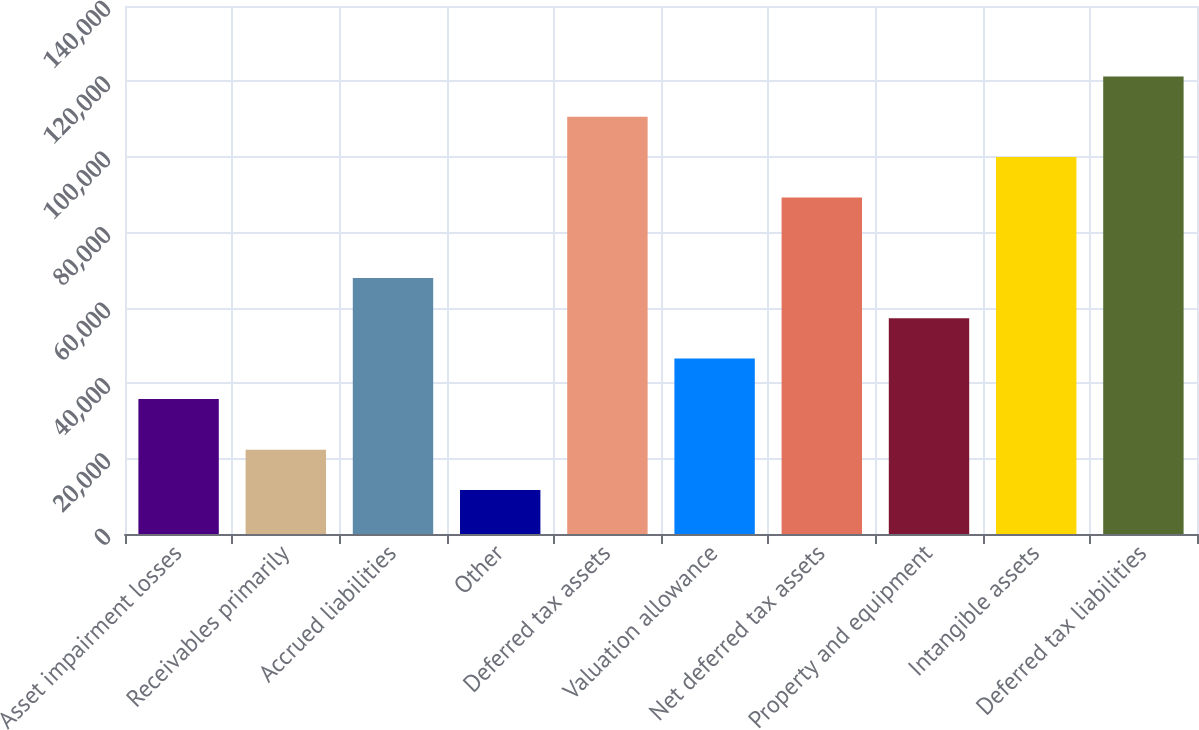<chart> <loc_0><loc_0><loc_500><loc_500><bar_chart><fcel>Asset impairment losses<fcel>Receivables primarily<fcel>Accrued liabilities<fcel>Other<fcel>Deferred tax assets<fcel>Valuation allowance<fcel>Net deferred tax assets<fcel>Property and equipment<fcel>Intangible assets<fcel>Deferred tax liabilities<nl><fcel>35817<fcel>22369<fcel>67875<fcel>11683<fcel>110619<fcel>46503<fcel>89247<fcel>57189<fcel>99933<fcel>121305<nl></chart> 